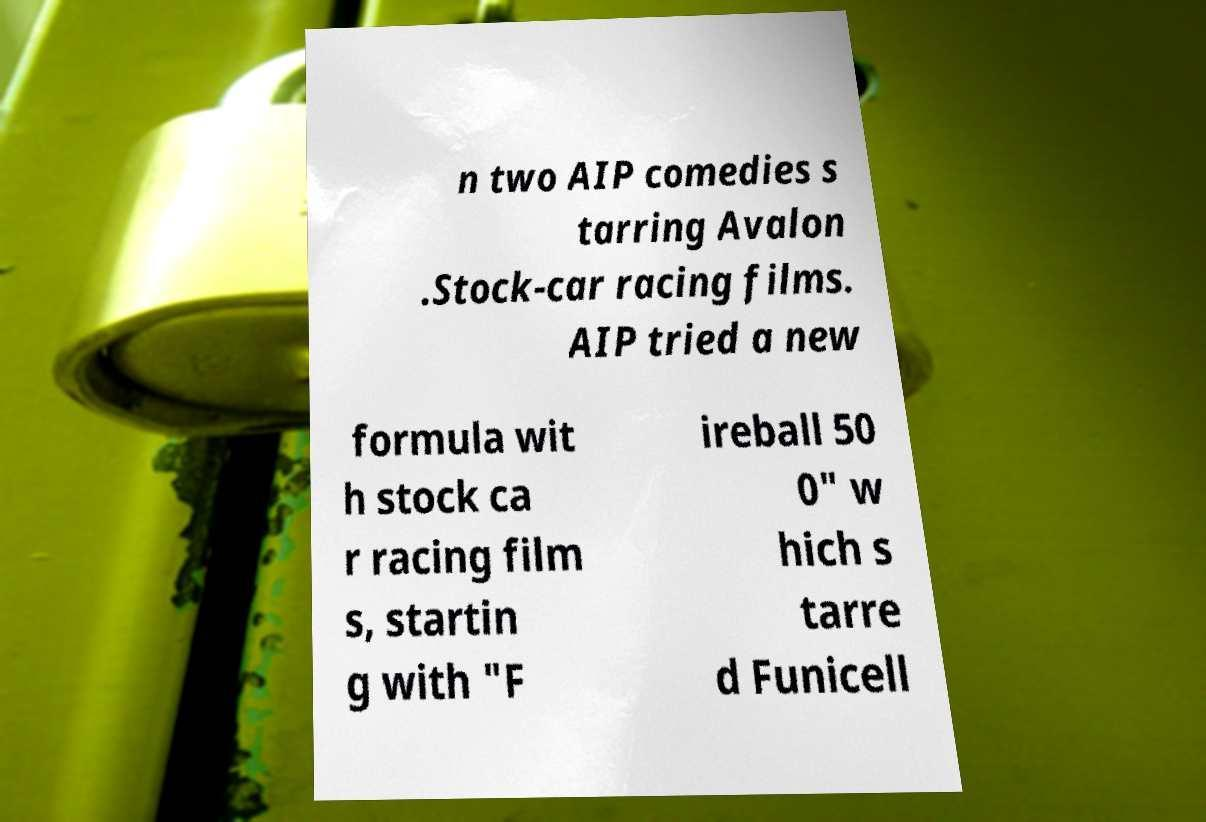Can you accurately transcribe the text from the provided image for me? n two AIP comedies s tarring Avalon .Stock-car racing films. AIP tried a new formula wit h stock ca r racing film s, startin g with "F ireball 50 0" w hich s tarre d Funicell 